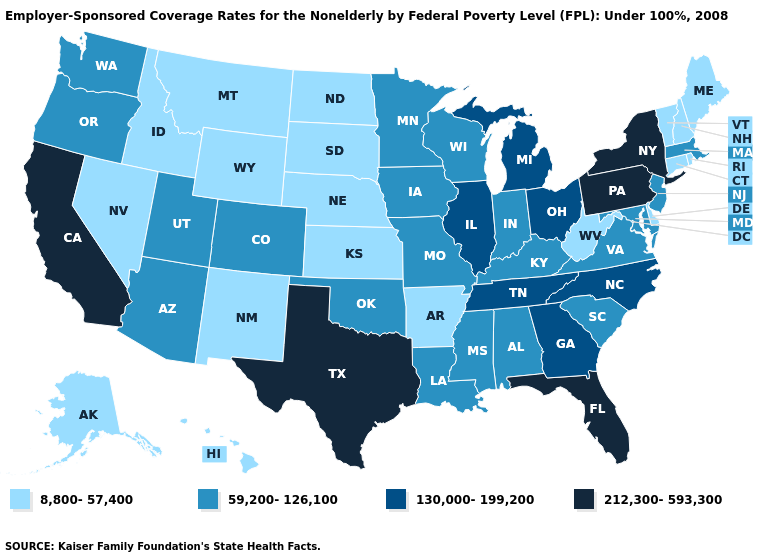Which states have the lowest value in the West?
Give a very brief answer. Alaska, Hawaii, Idaho, Montana, Nevada, New Mexico, Wyoming. Does Kansas have the lowest value in the USA?
Concise answer only. Yes. Does the first symbol in the legend represent the smallest category?
Be succinct. Yes. Among the states that border Oregon , which have the lowest value?
Answer briefly. Idaho, Nevada. Does Texas have the highest value in the South?
Concise answer only. Yes. Name the states that have a value in the range 130,000-199,200?
Answer briefly. Georgia, Illinois, Michigan, North Carolina, Ohio, Tennessee. Name the states that have a value in the range 130,000-199,200?
Quick response, please. Georgia, Illinois, Michigan, North Carolina, Ohio, Tennessee. Does Texas have the highest value in the USA?
Concise answer only. Yes. Does Minnesota have a higher value than South Dakota?
Concise answer only. Yes. Name the states that have a value in the range 130,000-199,200?
Give a very brief answer. Georgia, Illinois, Michigan, North Carolina, Ohio, Tennessee. What is the lowest value in the MidWest?
Short answer required. 8,800-57,400. Among the states that border Minnesota , which have the highest value?
Be succinct. Iowa, Wisconsin. Does Wyoming have the lowest value in the USA?
Be succinct. Yes. How many symbols are there in the legend?
Be succinct. 4. Name the states that have a value in the range 212,300-593,300?
Answer briefly. California, Florida, New York, Pennsylvania, Texas. 